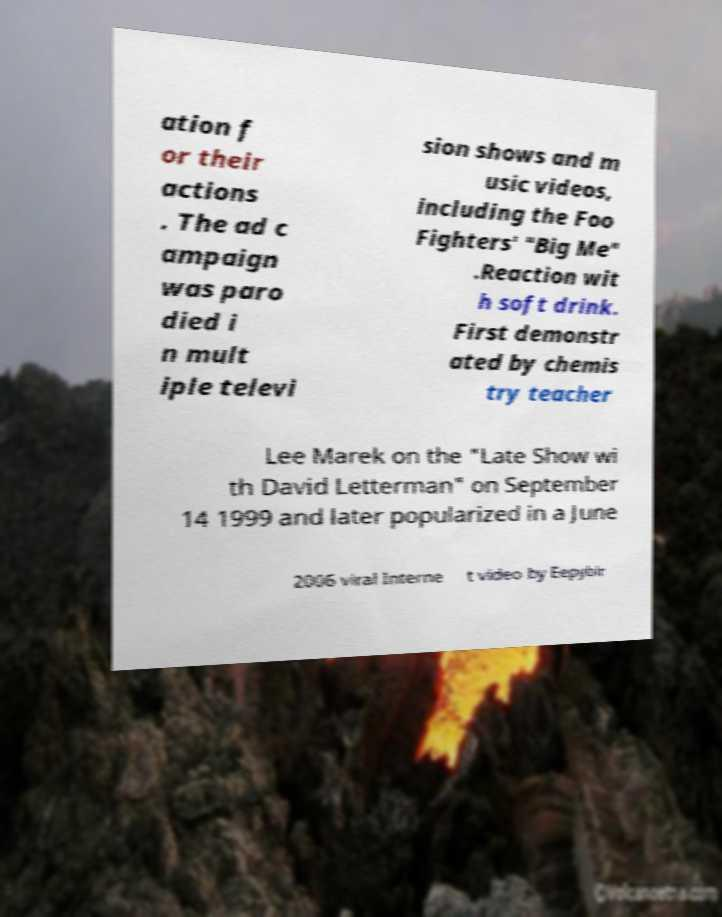What messages or text are displayed in this image? I need them in a readable, typed format. ation f or their actions . The ad c ampaign was paro died i n mult iple televi sion shows and m usic videos, including the Foo Fighters' "Big Me" .Reaction wit h soft drink. First demonstr ated by chemis try teacher Lee Marek on the "Late Show wi th David Letterman" on September 14 1999 and later popularized in a June 2006 viral Interne t video by Eepybir 